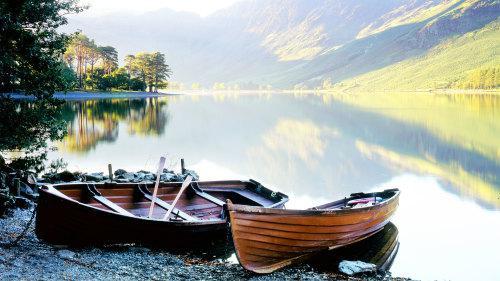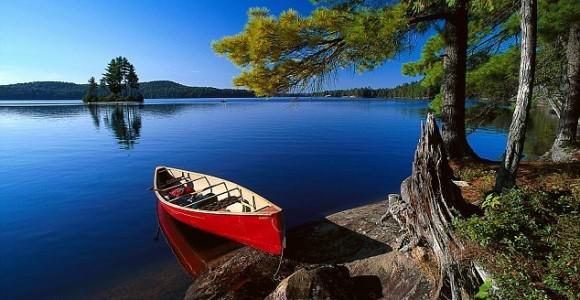The first image is the image on the left, the second image is the image on the right. Assess this claim about the two images: "there is a canoe on the beach with a row of tree trunks to the right". Correct or not? Answer yes or no. Yes. The first image is the image on the left, the second image is the image on the right. For the images shown, is this caption "There are at least four boats in total." true? Answer yes or no. No. 